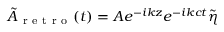Convert formula to latex. <formula><loc_0><loc_0><loc_500><loc_500>\tilde { A } _ { r e t r o } ( t ) = A e ^ { - i k z } e ^ { - i k c t } \tilde { \eta }</formula> 